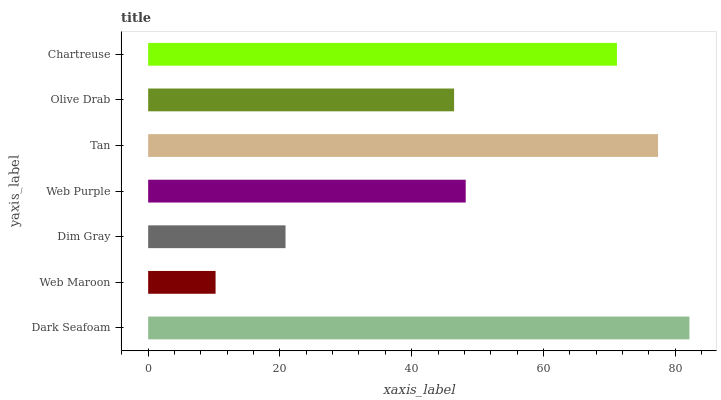Is Web Maroon the minimum?
Answer yes or no. Yes. Is Dark Seafoam the maximum?
Answer yes or no. Yes. Is Dim Gray the minimum?
Answer yes or no. No. Is Dim Gray the maximum?
Answer yes or no. No. Is Dim Gray greater than Web Maroon?
Answer yes or no. Yes. Is Web Maroon less than Dim Gray?
Answer yes or no. Yes. Is Web Maroon greater than Dim Gray?
Answer yes or no. No. Is Dim Gray less than Web Maroon?
Answer yes or no. No. Is Web Purple the high median?
Answer yes or no. Yes. Is Web Purple the low median?
Answer yes or no. Yes. Is Dark Seafoam the high median?
Answer yes or no. No. Is Web Maroon the low median?
Answer yes or no. No. 